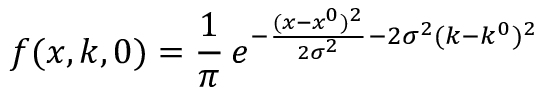Convert formula to latex. <formula><loc_0><loc_0><loc_500><loc_500>f ( x , k , 0 ) = \frac { 1 } { \pi } \, e ^ { - \frac { ( x - x ^ { 0 } ) ^ { 2 } } { 2 \sigma ^ { 2 } } - 2 \sigma ^ { 2 } ( k - k ^ { 0 } ) ^ { 2 } }</formula> 